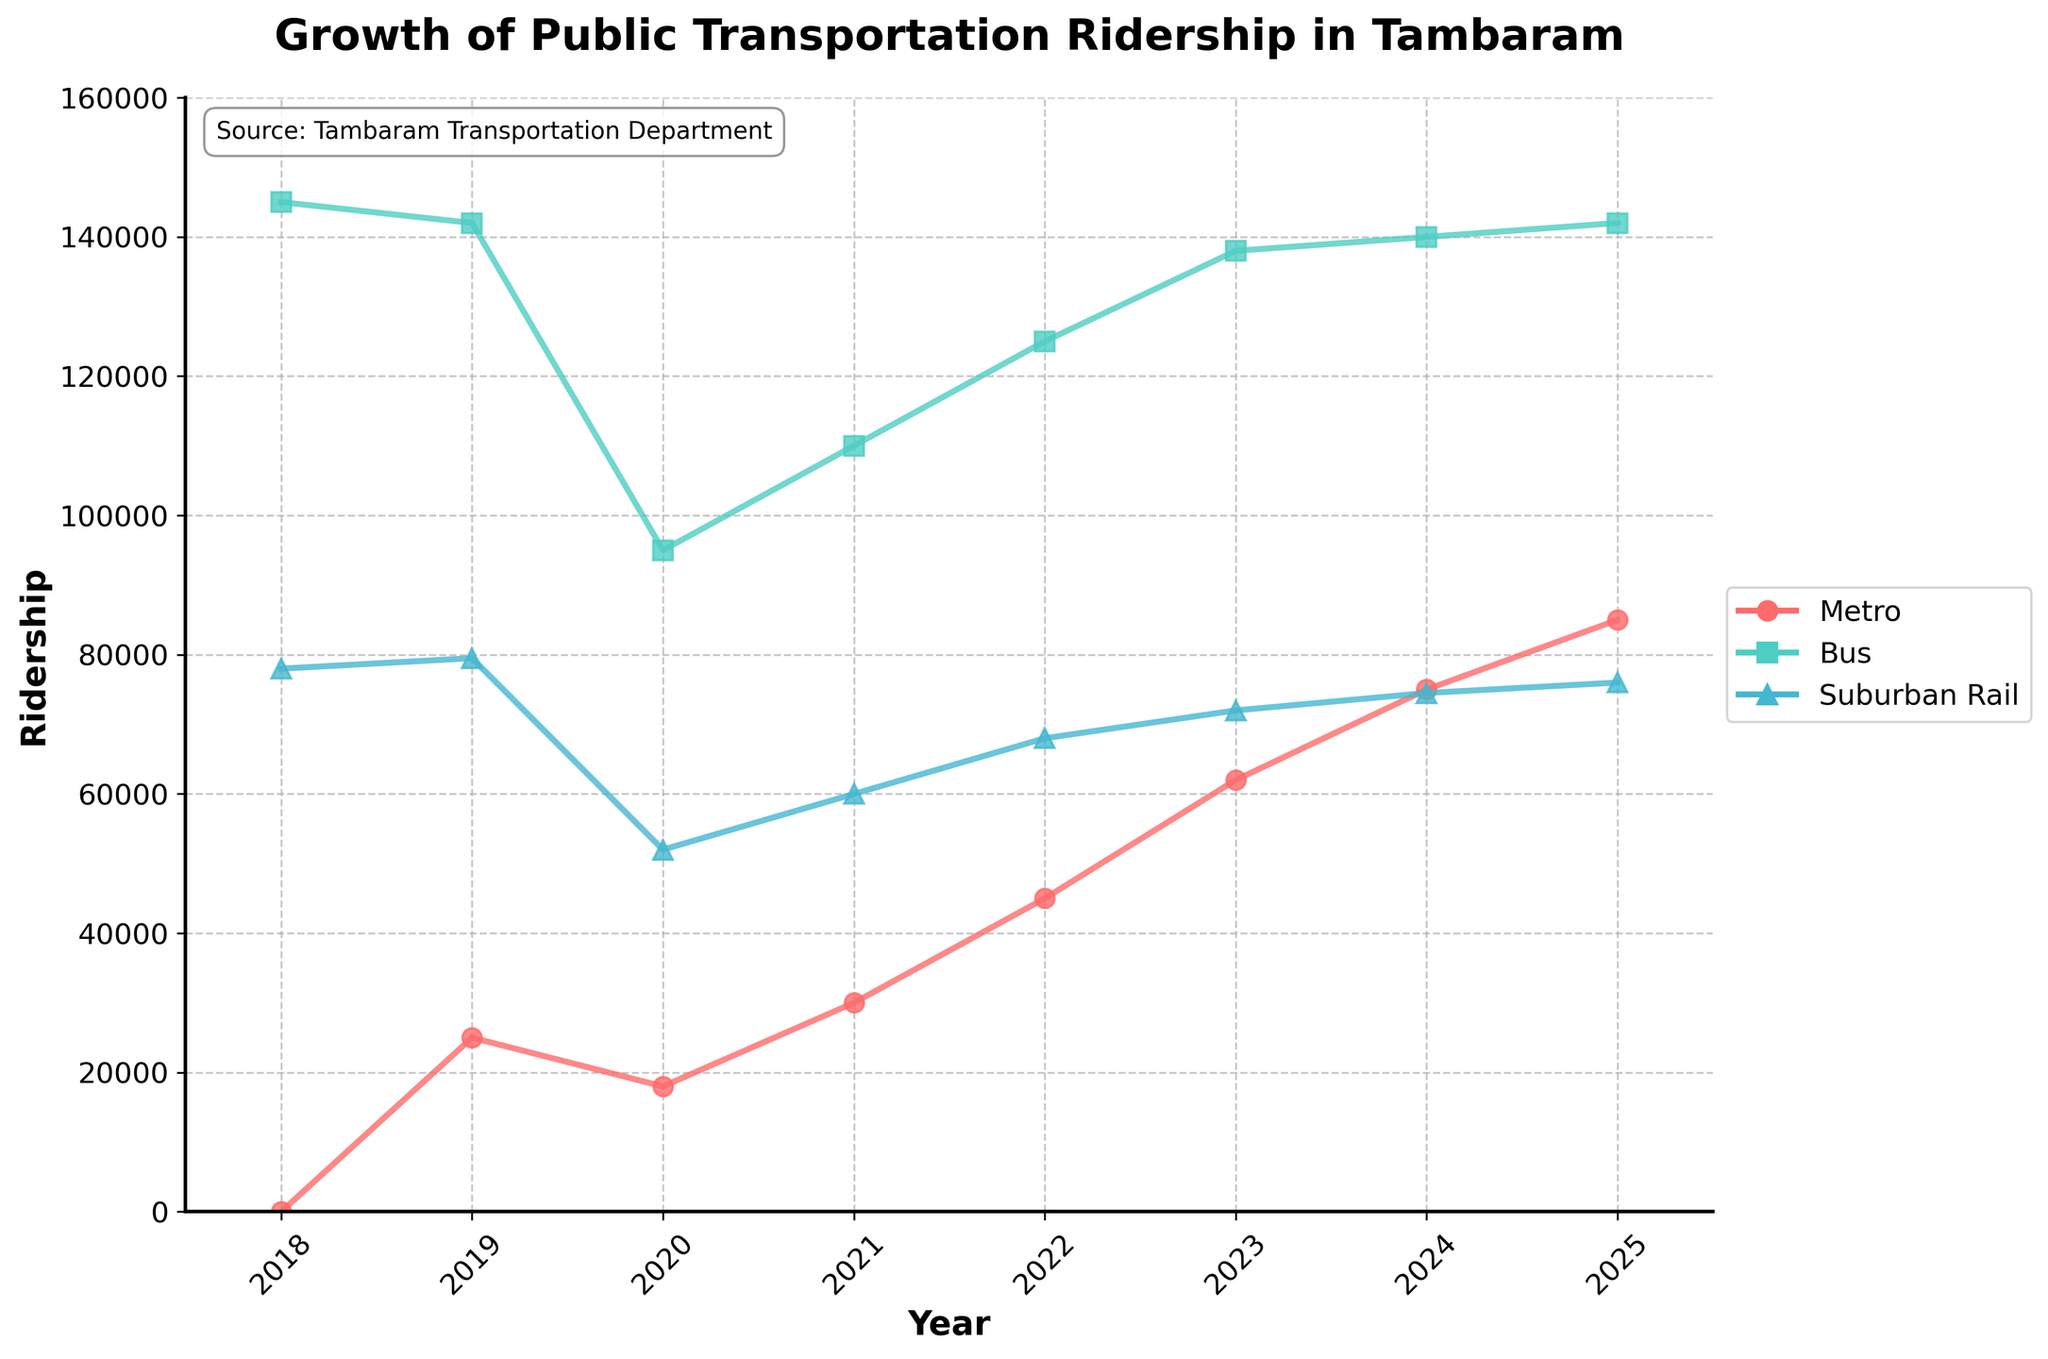How did bus ridership change from 2018 to 2025? To find the change in bus ridership, we subtract the 2018 bus ridership from the 2025 bus ridership. The ridership in 2018 is 145,000 and in 2025 it is 142,000. Thus, the difference is 145,000 - 142,000.
Answer: -3,000 What is the highest ridership value among the three modes of transportation in 2025? By examining the ridership values for all three modes of transportation in 2025, we see that Metro Ridership is 85,000, Bus Ridership is 142,000, and Suburban Rail Ridership is 76,000. The highest value among them is the bus ridership.
Answer: 142,000 Between 2020 and 2021, which mode of transportation saw an increase in ridership? We need to compare the ridership values for each mode in 2020 and 2021. Metro Ridership went from 18,000 to 30,000, Bus Ridership went from 95,000 to 110,000, and Suburban Rail Ridership went from 52,000 to 60,000. All three modes saw an increase, but we need to specify that all increased.
Answer: All What's the average annual growth of Metro Ridership from 2018 to 2025? Calculate the difference in ridership between 2025 and 2018. Then divide this by the number of years (2025-2018 = 7). Metro Ridership in 2025 is 85,000 and in 2018 is 0. Hence, the average annual growth is (85,000 - 0) / 7.
Answer: 12,143 Which year saw the sharpest increase in Metro Ridership? We need to look at the differences year by year. The greatest difference is between consecutive years. By examining year-over-year changes, we see that the biggest jump is from 2022 to 2023 where it goes from 45,000 to 62,000. The increase is 17,000.
Answer: 2023 Has Bus Ridership ever decreased from one year to another between 2018 and 2025? Check the values year by year to see if there is any decrease. In every year from 2018 to 2025, bus ridership values either increased or remained constant, but never decreased.
Answer: No How does the ridership of Suburban Rail in 2025 compare to that in 2020? To compare the ridership of Suburban Rail, subtract the value in 2020 from that in 2025. Suburban Rail Ridership in 2025 is 76,000 and in 2020 is 52,000. Hence, 76,000 - 52,000.
Answer: 24,000 Which mode of transportation had the highest increase in absolute numbers from 2018 to 2025? Calculate the increase for each mode by subtracting the 2018 ridership from the 2025 ridership. Metro goes from 0 to 85,000 (increase of 85,000), Bus goes from 145,000 to 142,000 (decrease of 3,000), and Suburban Rail goes from 78,000 to 76,000 (decrease of 2,000). Metro has the highest increase.
Answer: Metro In which year did the Metro Ridership surpass Bus Ridership for the first time? Compare the Metro and Bus ridership values side-by-side for every year. The Metro Ridership never surpassed the Bus Ridership in any year according to the provided data.
Answer: Never How many more people used the Bus compared to the Metro in 2024? Subtract the Metro Ridership from the Bus Ridership for the year 2024. Bus Ridership is 140,000 and Metro Ridership is 75,000. Hence, 140,000 - 75,000.
Answer: 65,000 